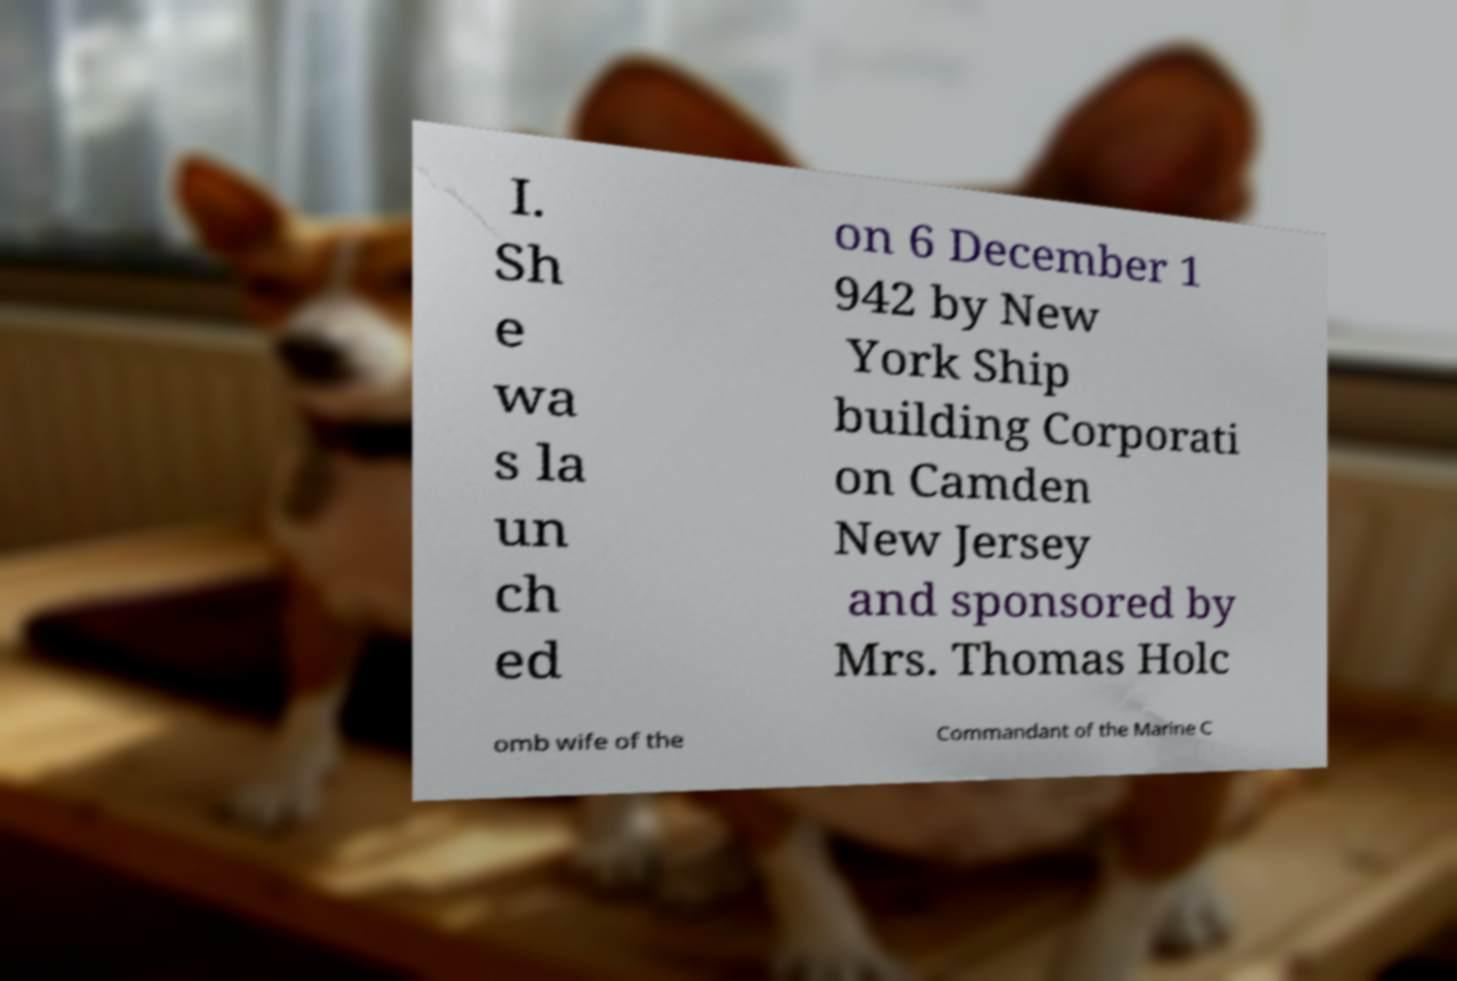Please identify and transcribe the text found in this image. I. Sh e wa s la un ch ed on 6 December 1 942 by New York Ship building Corporati on Camden New Jersey and sponsored by Mrs. Thomas Holc omb wife of the Commandant of the Marine C 